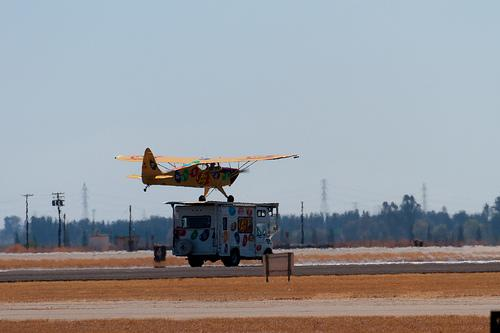Provide a brief summary of the overall scene in the image. A yellow glider plane is sitting on top of a white truck filled with stickers, surrounded by signs, trees, and poles with a clear blue sky overhead. Explain the position of the plane in relation to the truck. The small yellow plane is conveniently placed on top of the white truck. Describe the condition of the street in the image. The street is made of dark grey asphalt and is covered with a layer of yellow and brown grass. Mention an interesting detail about the plane. The glider plane has large orange wings on top and two wheels on the bottom. Mention an interesting feature of the truck in the image. The white truck has numerous drawings and stickers all over its body. Briefly explain the natural environment and elements in the image. The image features a clear blue sky with no clouds, brown grass on the ground, and trees in the distance. Describe the appearance and state of the plane in the image. The plane is a small, yellow glider with orange wings, rudder wings, and tail, resting on top of a truck. Describe a man-made feature in the image other than the plane and truck. There is a small signboard near the truck, placed in the ground next to the street. 